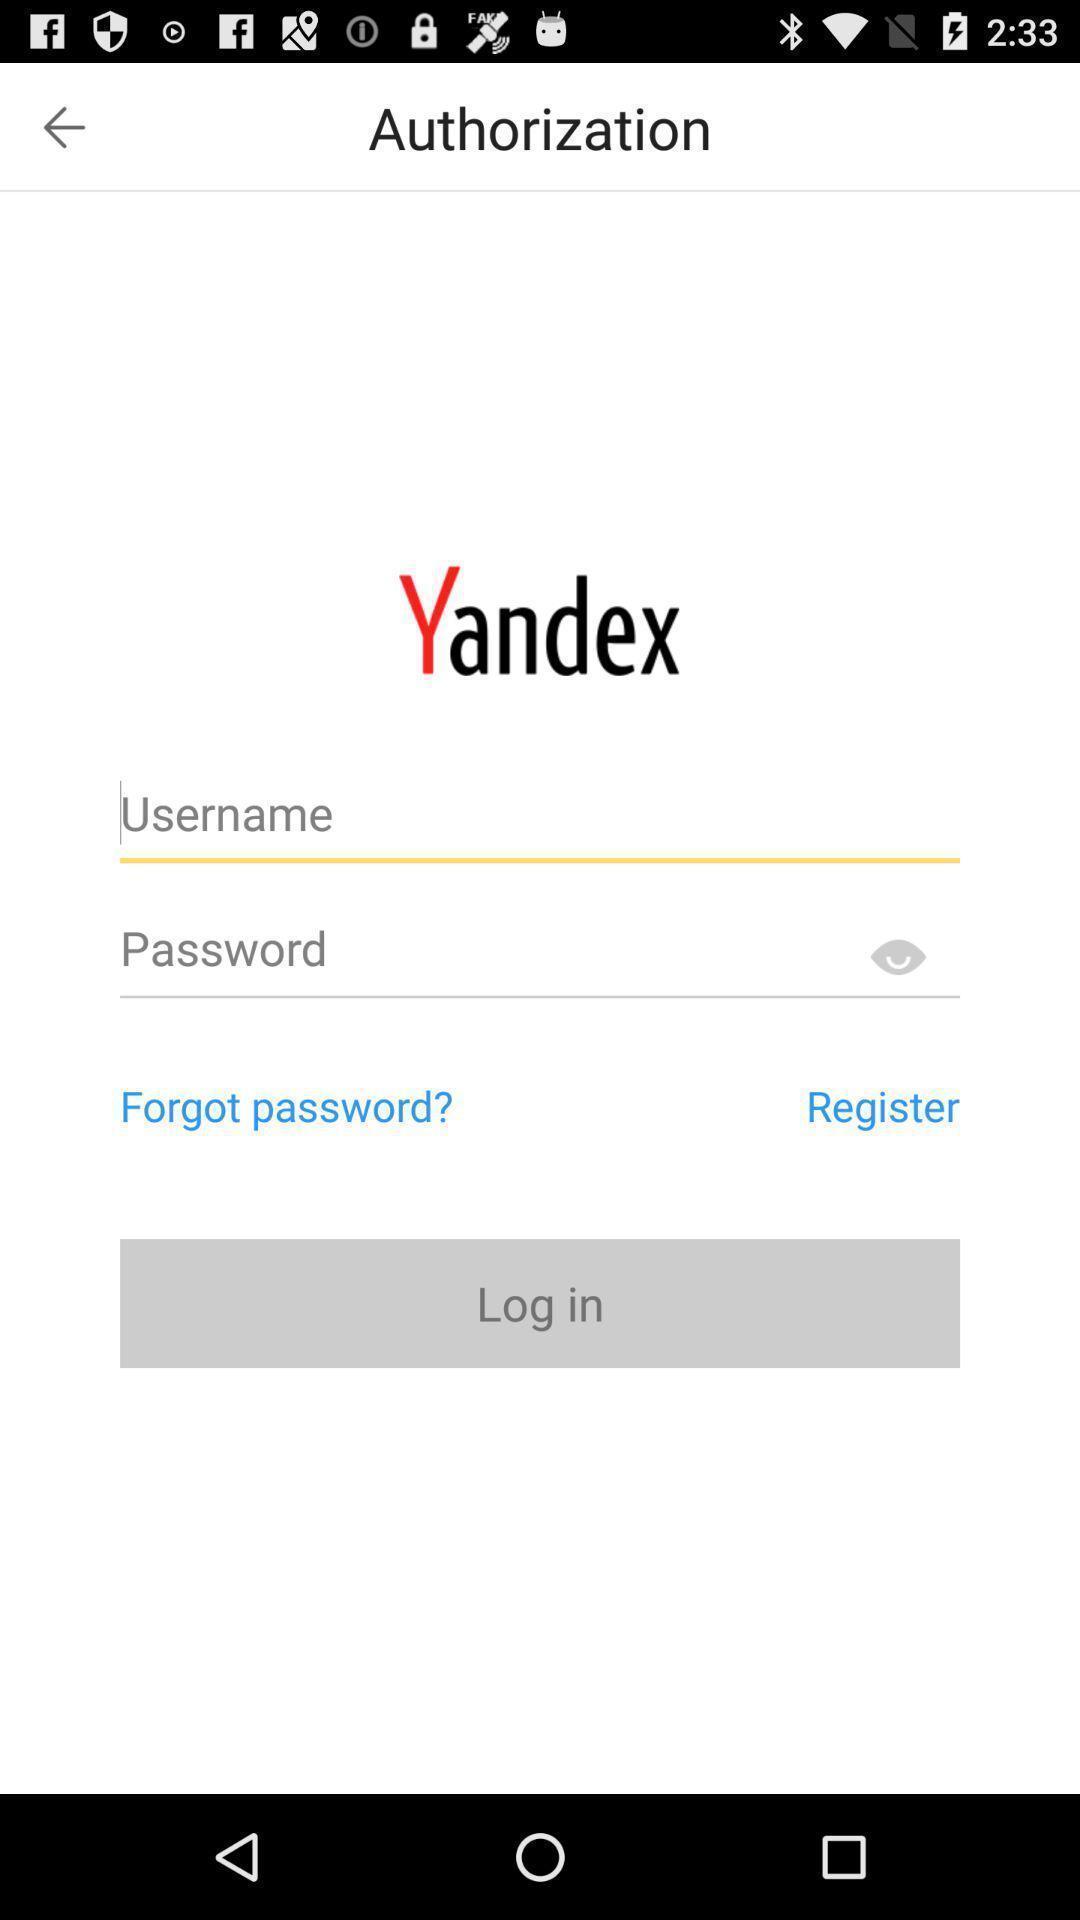What details can you identify in this image? Welcome to the login page. 